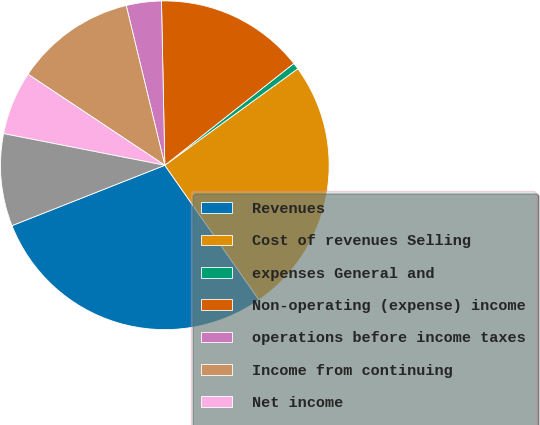Convert chart. <chart><loc_0><loc_0><loc_500><loc_500><pie_chart><fcel>Revenues<fcel>Cost of revenues Selling<fcel>expenses General and<fcel>Non-operating (expense) income<fcel>operations before income taxes<fcel>Income from continuing<fcel>Net income<fcel>Net income attributable to<nl><fcel>28.73%<fcel>25.28%<fcel>0.64%<fcel>14.69%<fcel>3.45%<fcel>11.88%<fcel>6.26%<fcel>9.07%<nl></chart> 